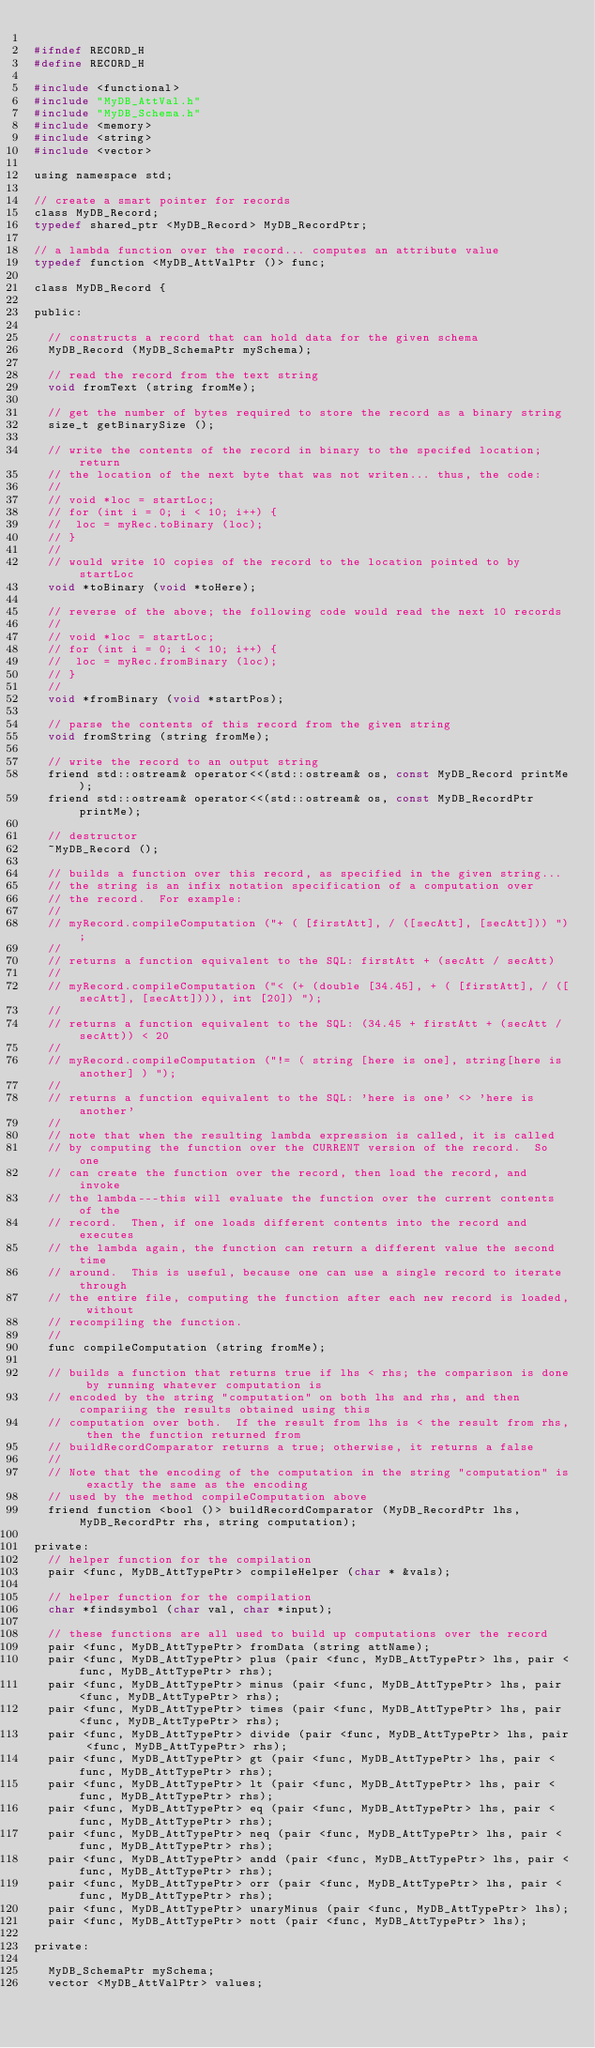<code> <loc_0><loc_0><loc_500><loc_500><_C_>
#ifndef RECORD_H
#define RECORD_H

#include <functional>
#include "MyDB_AttVal.h"
#include "MyDB_Schema.h"
#include <memory>
#include <string>
#include <vector>

using namespace std;

// create a smart pointer for records
class MyDB_Record;
typedef shared_ptr <MyDB_Record> MyDB_RecordPtr;

// a lambda function over the record... computes an attribute value
typedef function <MyDB_AttValPtr ()> func;

class MyDB_Record {

public:

	// constructs a record that can hold data for the given schema
	MyDB_Record (MyDB_SchemaPtr mySchema);

	// read the record from the text string
	void fromText (string fromMe);

	// get the number of bytes required to store the record as a binary string
	size_t getBinarySize ();

	// write the contents of the record in binary to the specifed location; return
	// the location of the next byte that was not writen... thus, the code:
	//
	// void *loc = startLoc;
	// for (int i = 0; i < 10; i++) {
	// 	loc = myRec.toBinary (loc);
	// }
	// 	
	// would write 10 copies of the record to the location pointed to by startLoc
	void *toBinary (void *toHere);

	// reverse of the above; the following code would read the next 10 records
	//
	// void *loc = startLoc;
	// for (int i = 0; i < 10; i++) {
	// 	loc = myRec.fromBinary (loc);
	// }
	// 	
	void *fromBinary (void *startPos);

	// parse the contents of this record from the given string
	void fromString (string fromMe);

	// write the record to an output string
	friend std::ostream& operator<<(std::ostream& os, const MyDB_Record printMe);
	friend std::ostream& operator<<(std::ostream& os, const MyDB_RecordPtr printMe);
	
	// destructor
	~MyDB_Record ();

	// builds a function over this record, as specified in the given string...
	// the string is an infix notation specification of a computation over
	// the record.  For example:
	//
	// myRecord.compileComputation ("+ ( [firstAtt], / ([secAtt], [secAtt])) ");
	// 
	// returns a function equivalent to the SQL: firstAtt + (secAtt / secAtt)
	//
	// myRecord.compileComputation ("< (+ (double [34.45], + ( [firstAtt], / ([secAtt], [secAtt]))), int [20]) ");
	//
	// returns a function equivalent to the SQL: (34.45 + firstAtt + (secAtt / secAtt)) < 20
	//
	// myRecord.compileComputation ("!= ( string [here is one], string[here is another] ) ");
	//
	// returns a function equivalent to the SQL: 'here is one' <> 'here is another'
	//
	// note that when the resulting lambda expression is called, it is called
	// by computing the function over the CURRENT version of the record.  So one
	// can create the function over the record, then load the record, and invoke
	// the lambda---this will evaluate the function over the current contents of the
	// record.  Then, if one loads different contents into the record and executes
	// the lambda again, the function can return a different value the second time
	// around.  This is useful, because one can use a single record to iterate through
	// the entire file, computing the function after each new record is loaded, without
	// recompiling the function.
	//
	func compileComputation (string fromMe);

	// builds a function that returns true if lhs < rhs; the comparison is done by running whatever computation is 
	// encoded by the string "computation" on both lhs and rhs, and then compariing the results obtained using this
	// computation over both.  If the result from lhs is < the result from rhs, then the function returned from
	// buildRecordComparator returns a true; otherwise, it returns a false
	//
	// Note that the encoding of the computation in the string "computation" is exactly the same as the encoding
	// used by the method compileComputation above
	friend function <bool ()> buildRecordComparator (MyDB_RecordPtr lhs,  MyDB_RecordPtr rhs, string computation);

private:
	// helper function for the compilation
	pair <func, MyDB_AttTypePtr> compileHelper (char * &vals);

	// helper function for the compilation
	char *findsymbol (char val, char *input);
	
	// these functions are all used to build up computations over the record
	pair <func, MyDB_AttTypePtr> fromData (string attName);
	pair <func, MyDB_AttTypePtr> plus (pair <func, MyDB_AttTypePtr> lhs, pair <func, MyDB_AttTypePtr> rhs);
	pair <func, MyDB_AttTypePtr> minus (pair <func, MyDB_AttTypePtr> lhs, pair <func, MyDB_AttTypePtr> rhs);
	pair <func, MyDB_AttTypePtr> times (pair <func, MyDB_AttTypePtr> lhs, pair <func, MyDB_AttTypePtr> rhs);
	pair <func, MyDB_AttTypePtr> divide (pair <func, MyDB_AttTypePtr> lhs, pair <func, MyDB_AttTypePtr> rhs);
	pair <func, MyDB_AttTypePtr> gt (pair <func, MyDB_AttTypePtr> lhs, pair <func, MyDB_AttTypePtr> rhs);
	pair <func, MyDB_AttTypePtr> lt (pair <func, MyDB_AttTypePtr> lhs, pair <func, MyDB_AttTypePtr> rhs);
	pair <func, MyDB_AttTypePtr> eq (pair <func, MyDB_AttTypePtr> lhs, pair <func, MyDB_AttTypePtr> rhs);
	pair <func, MyDB_AttTypePtr> neq (pair <func, MyDB_AttTypePtr> lhs, pair <func, MyDB_AttTypePtr> rhs);
	pair <func, MyDB_AttTypePtr> andd (pair <func, MyDB_AttTypePtr> lhs, pair <func, MyDB_AttTypePtr> rhs);
	pair <func, MyDB_AttTypePtr> orr (pair <func, MyDB_AttTypePtr> lhs, pair <func, MyDB_AttTypePtr> rhs);
	pair <func, MyDB_AttTypePtr> unaryMinus (pair <func, MyDB_AttTypePtr> lhs);
	pair <func, MyDB_AttTypePtr> nott (pair <func, MyDB_AttTypePtr> lhs);

private:

	MyDB_SchemaPtr mySchema;
	vector <MyDB_AttValPtr> values;	</code> 